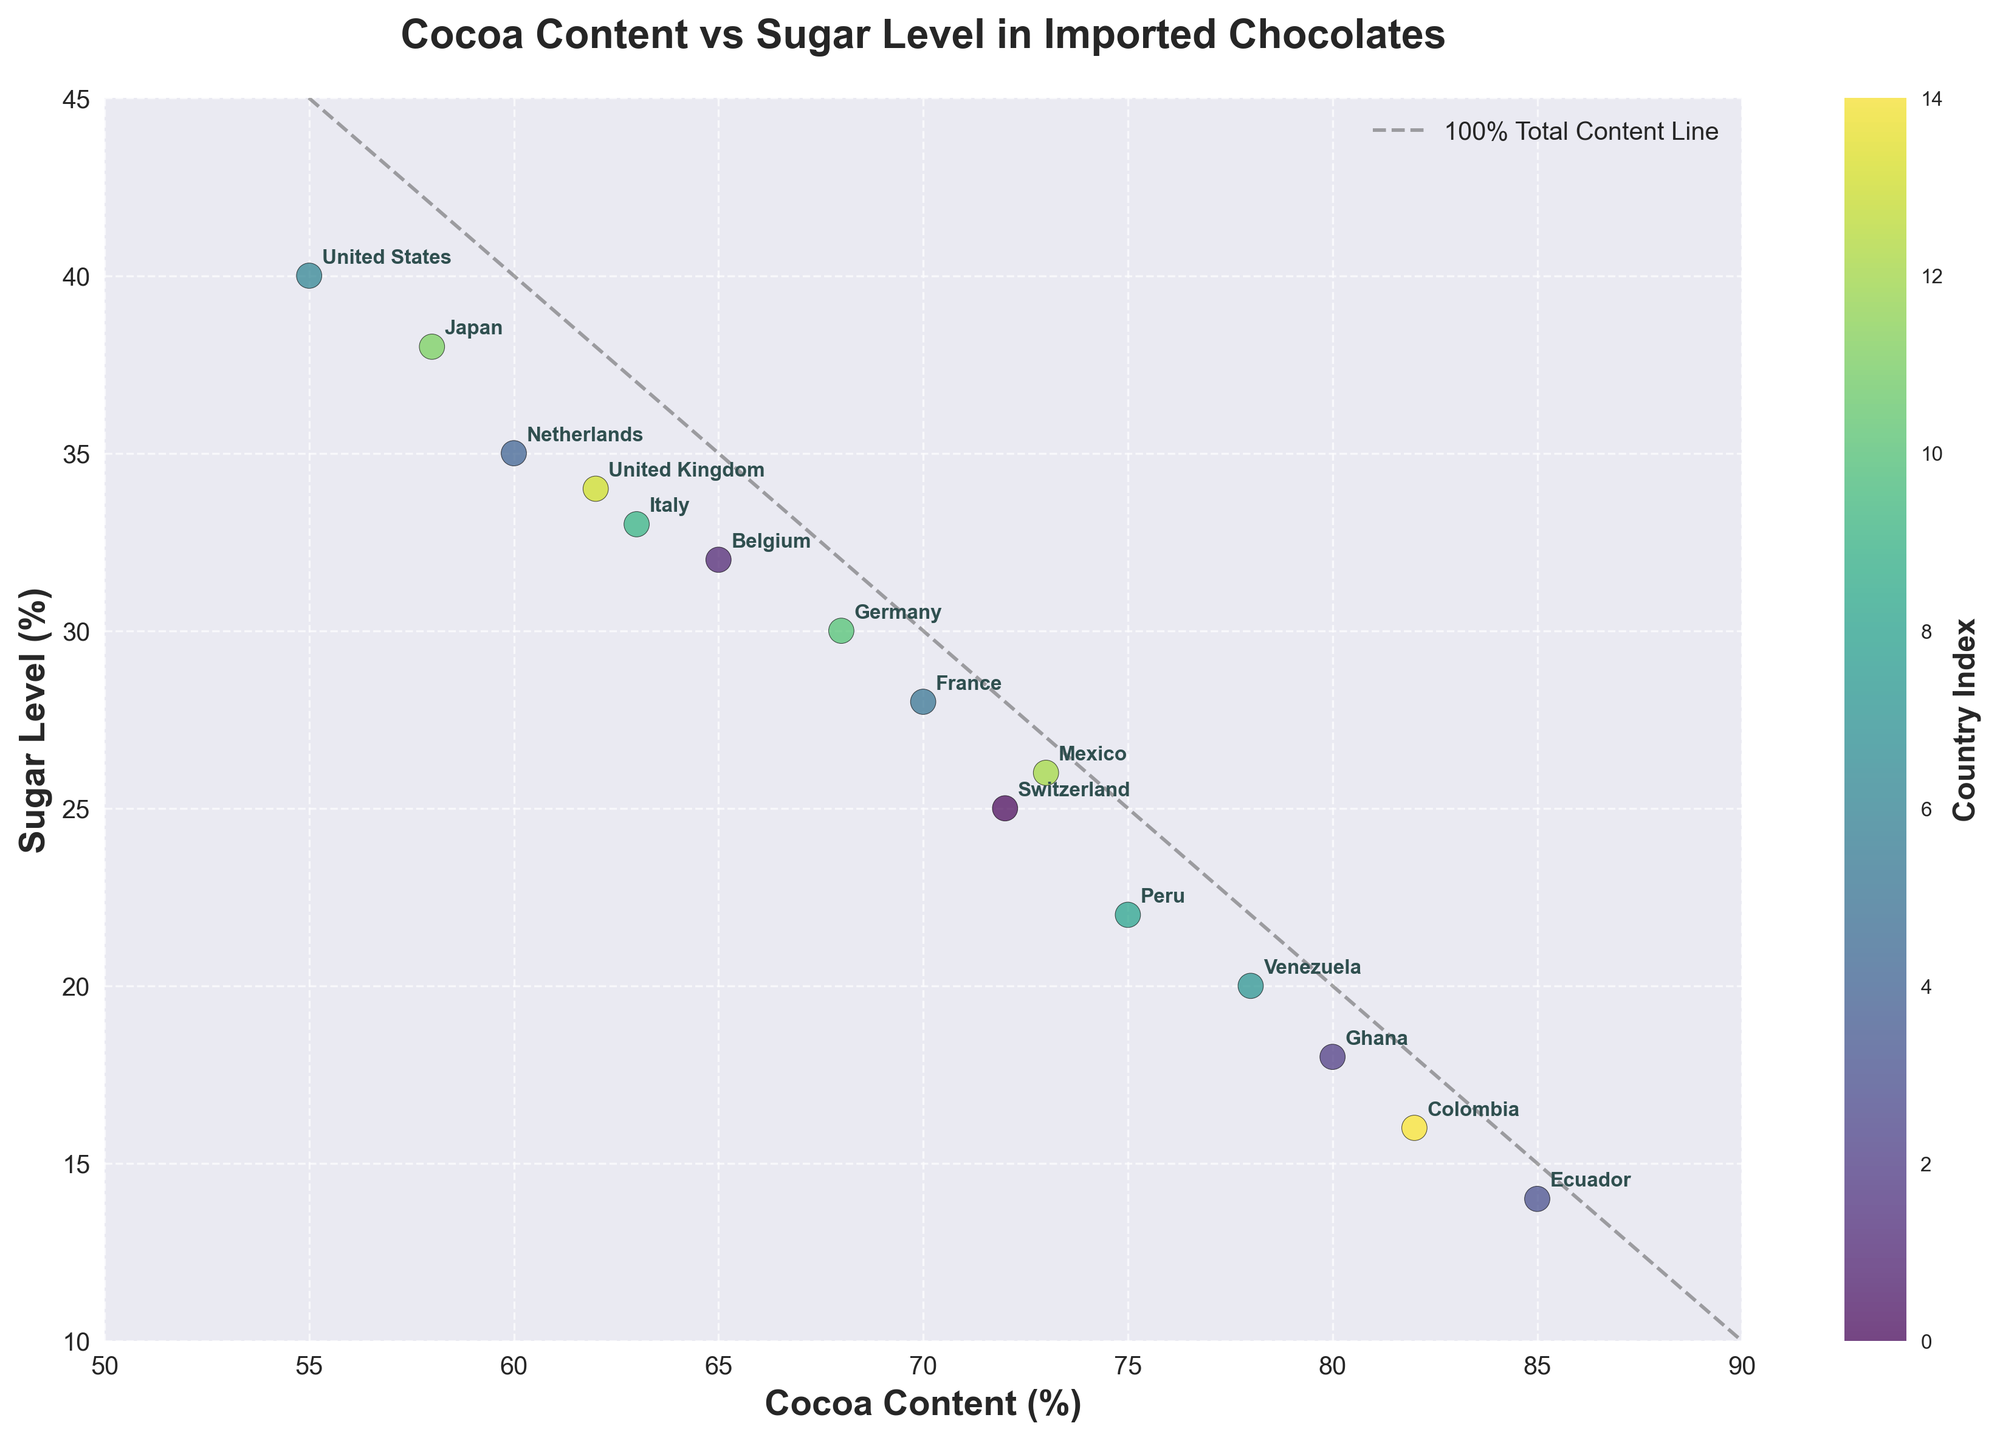How many countries are represented in the plot? Count the number of distinct labels on the plot.
Answer: 15 What is the title of the plot? Read the title text at the top of the plot.
Answer: Cocoa Content vs Sugar Level in Imported Chocolates Which country has the highest cocoa content? Find the label corresponding to the highest value on the x-axis.
Answer: Ecuador Which country has the lowest sugar level? Find the label corresponding to the lowest value on the y-axis.
Answer: Ecuador What is the cocoa content of chocolates from the United States? Locate the United States label on the plot and read the x-axis value.
Answer: 55% Which two countries have the closest cocoa content values? Compare the x-axis values and find the smallest difference between two country labels.
Answer: Belgium and Italy What's the average sugar level of chocolates from Switzerland, France, and Germany? Read the sugar levels for Switzerland (25), France (28), and Germany (30), and then calculate the average (25 + 28 + 30) / 3.
Answer: 27.67% Is the cocoa content for chocolates from Mexico higher than that from France? Compare the cocoa content of Mexico (73) and France (70) on the x-axis.
Answer: Yes Which country has chocolates with both the highest cocoa and lowest sugar levels? Identify the country label that overlaps with the highest x-axis value and the lowest y-axis value.
Answer: Ecuador How many countries have chocolates with a sugar level above 30%? Count the number of country labels with a y-axis value greater than 30.
Answer: 5 